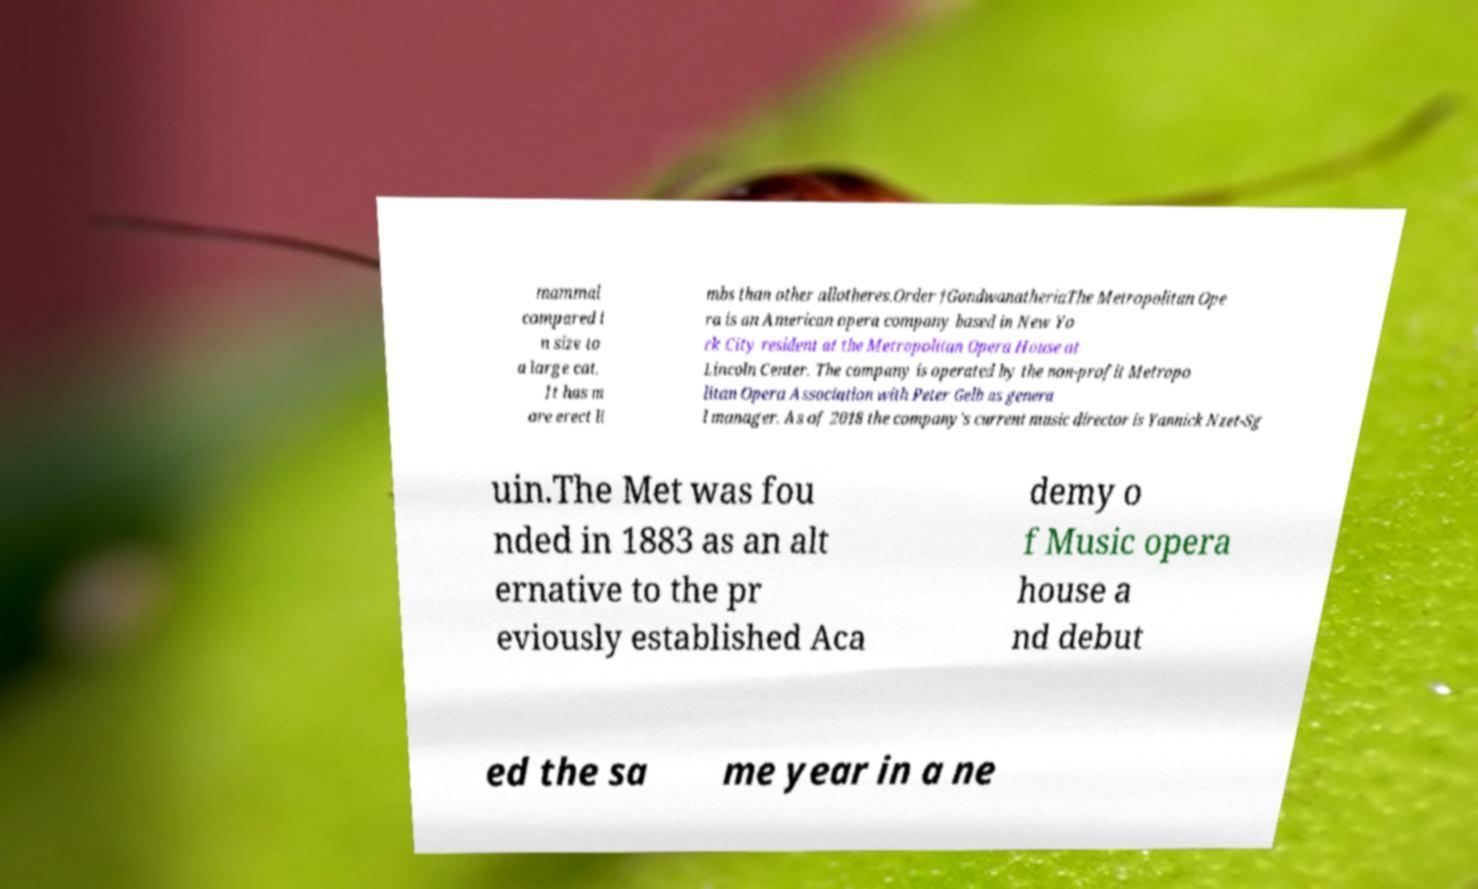There's text embedded in this image that I need extracted. Can you transcribe it verbatim? mammal compared i n size to a large cat. It has m ore erect li mbs than other allotheres.Order †GondwanatheriaThe Metropolitan Ope ra is an American opera company based in New Yo rk City resident at the Metropolitan Opera House at Lincoln Center. The company is operated by the non-profit Metropo litan Opera Association with Peter Gelb as genera l manager. As of 2018 the company's current music director is Yannick Nzet-Sg uin.The Met was fou nded in 1883 as an alt ernative to the pr eviously established Aca demy o f Music opera house a nd debut ed the sa me year in a ne 